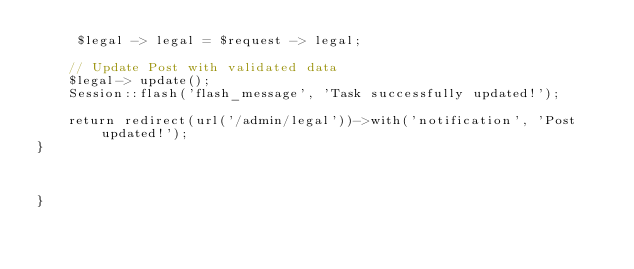Convert code to text. <code><loc_0><loc_0><loc_500><loc_500><_PHP_>     $legal -> legal = $request -> legal;

    // Update Post with validated data
    $legal-> update();
    Session::flash('flash_message', 'Task successfully updated!');

    return redirect(url('/admin/legal'))->with('notification', 'Post updated!');
}

    

}</code> 